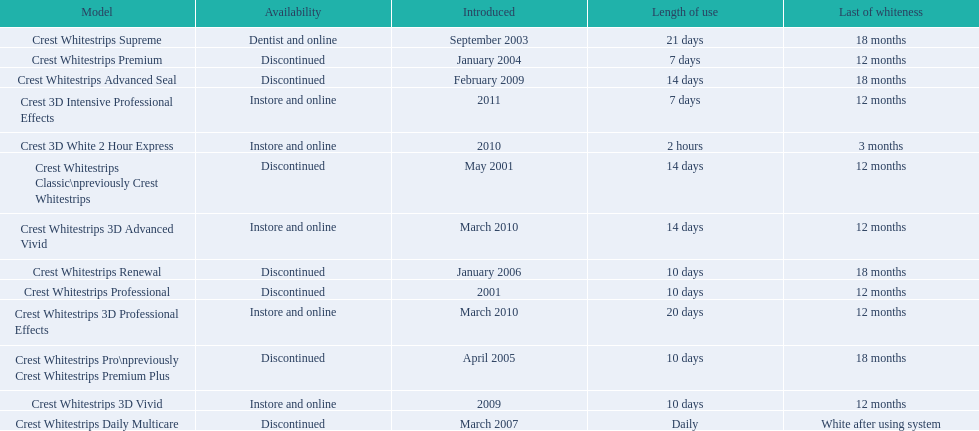What are all of the model names? Crest Whitestrips Classic\npreviously Crest Whitestrips, Crest Whitestrips Professional, Crest Whitestrips Supreme, Crest Whitestrips Premium, Crest Whitestrips Pro\npreviously Crest Whitestrips Premium Plus, Crest Whitestrips Renewal, Crest Whitestrips Daily Multicare, Crest Whitestrips Advanced Seal, Crest Whitestrips 3D Vivid, Crest Whitestrips 3D Advanced Vivid, Crest Whitestrips 3D Professional Effects, Crest 3D White 2 Hour Express, Crest 3D Intensive Professional Effects. When were they first introduced? May 2001, 2001, September 2003, January 2004, April 2005, January 2006, March 2007, February 2009, 2009, March 2010, March 2010, 2010, 2011. Along with crest whitestrips 3d advanced vivid, which other model was introduced in march 2010? Crest Whitestrips 3D Professional Effects. 